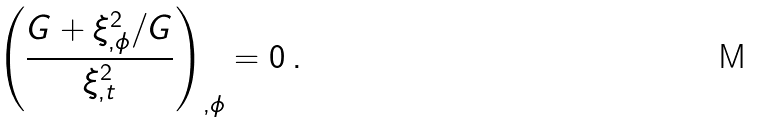Convert formula to latex. <formula><loc_0><loc_0><loc_500><loc_500>\left ( \frac { G + \xi _ { , \phi } ^ { 2 } / G } { \xi _ { , t } ^ { 2 } } \right ) _ { , \phi } = 0 \, .</formula> 